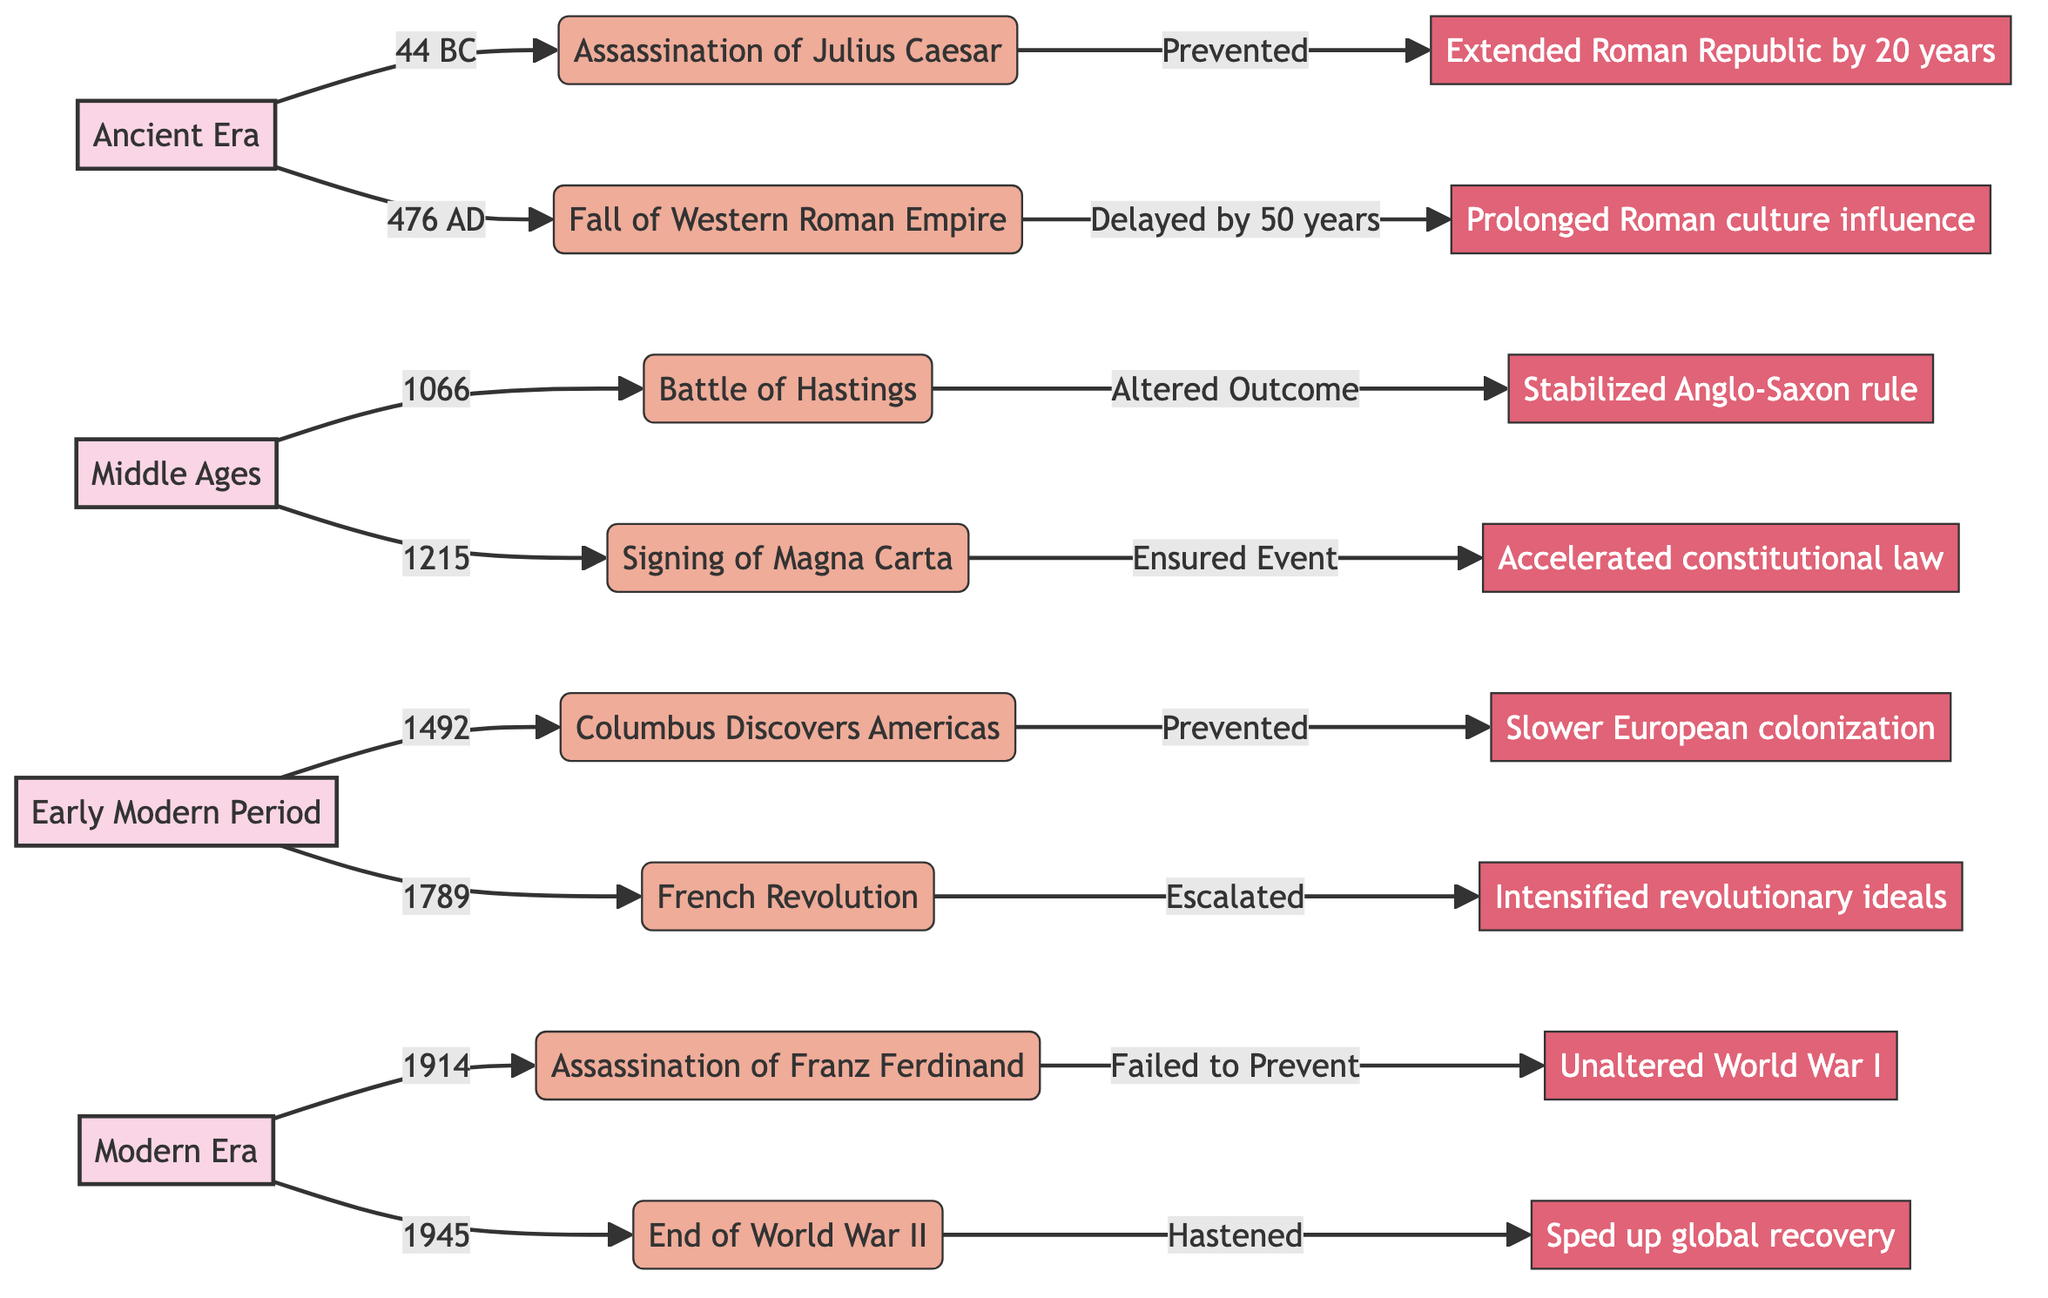What historical event occurred in 476 AD? The diagram indicates that the event in 476 AD is the Fall of Western Roman Empire. It is directly linked as a significant event within the Ancient Era period.
Answer: Fall of Western Roman Empire What was the ancillary effect of preventing the assassination of Julius Caesar? The diagram connects the prevention of the assassination to the ancillary effect of extending the Roman Republic by 20 years. This is found in the flow from Julius Caesar's assassination to its respective effect.
Answer: Extended duration of the Roman Republic by 20 years How many major historical events are listed for the Early Modern Period? The diagram shows two events labeled: "Columbus Discovers the Americas" and "French Revolution", which indicates that there are two major historical events in that period.
Answer: 2 What was the intervention in 1066 at the Battle of Hastings? According to the diagram, the intervention during the Battle of Hastings in 1066 was "Altered Outcome", which indicates a change in the expected result of this event.
Answer: Altered Outcome What effect did the intervention in 1789 have on revolutionary ideals? The diagram illustrates that the escalation of the French Revolution in 1789 intensified the spread of revolutionary ideals in Europe, connecting the event to its effect.
Answer: Intensified spread of revolutionary ideals in Europe What event was failed to be prevented in 1914? The diagram specifies that the failed prevention during 1914 refers to the Assassination of Archduke Franz Ferdinand, directly linking the intervention to the event.
Answer: Assassination of Archduke Franz Ferdinand Which period includes the event of signing the Magna Carta? The signing of the Magna Carta is found under the Middle Ages period, as indicated by its connection in the flowchart.
Answer: Middle Ages What was the effect of hastening the end of World War II in 1945? The diagram indicates that hastening the end of World War II resulted in speeding up reconstruction and global recovery post-war, thus linking the intervention to its ancillary effect.
Answer: Sped up reconstruction and global recovery post-war What is the relationship between the Fall of Western Roman Empire and Roman culture influence? The diagram shows that the Fall of Western Roman Empire in 476 AD was delayed by 50 years, which caused a prolonged influence of Roman culture in Europe; this demonstrates a direct relationship between the event and its effect.
Answer: Prolonged influence of Roman culture in Europe 